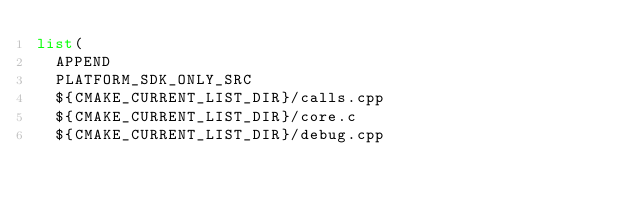<code> <loc_0><loc_0><loc_500><loc_500><_CMake_>list(
  APPEND
  PLATFORM_SDK_ONLY_SRC
  ${CMAKE_CURRENT_LIST_DIR}/calls.cpp
  ${CMAKE_CURRENT_LIST_DIR}/core.c
  ${CMAKE_CURRENT_LIST_DIR}/debug.cpp</code> 